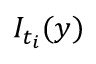<formula> <loc_0><loc_0><loc_500><loc_500>I _ { t _ { i } } ( y )</formula> 